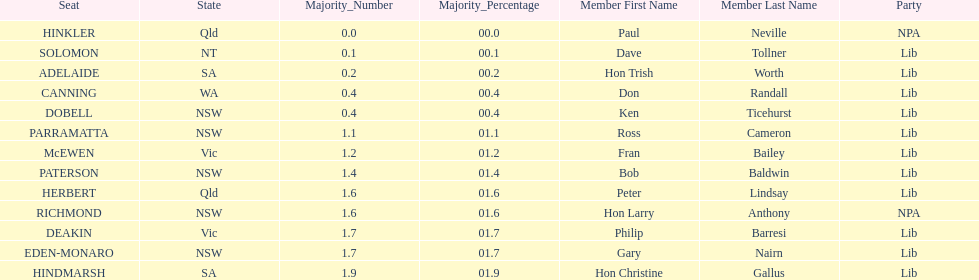What is the name of the last seat? HINDMARSH. 